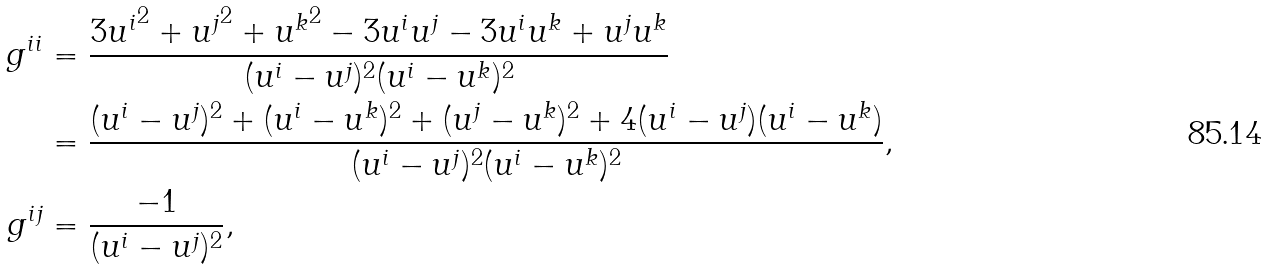Convert formula to latex. <formula><loc_0><loc_0><loc_500><loc_500>g ^ { i i } & = \frac { 3 { u ^ { i } } ^ { 2 } + { u ^ { j } } ^ { 2 } + { u ^ { k } } ^ { 2 } - 3 u ^ { i } u ^ { j } - 3 u ^ { i } u ^ { k } + u ^ { j } u ^ { k } } { ( u ^ { i } - u ^ { j } ) ^ { 2 } ( u ^ { i } - u ^ { k } ) ^ { 2 } } \\ & = \frac { ( u ^ { i } - u ^ { j } ) ^ { 2 } + ( u ^ { i } - u ^ { k } ) ^ { 2 } + ( u ^ { j } - u ^ { k } ) ^ { 2 } + 4 ( u ^ { i } - u ^ { j } ) ( u ^ { i } - u ^ { k } ) } { ( u ^ { i } - u ^ { j } ) ^ { 2 } ( u ^ { i } - u ^ { k } ) ^ { 2 } } , \\ g ^ { i j } & = \frac { - 1 } { ( u ^ { i } - u ^ { j } ) ^ { 2 } } ,</formula> 